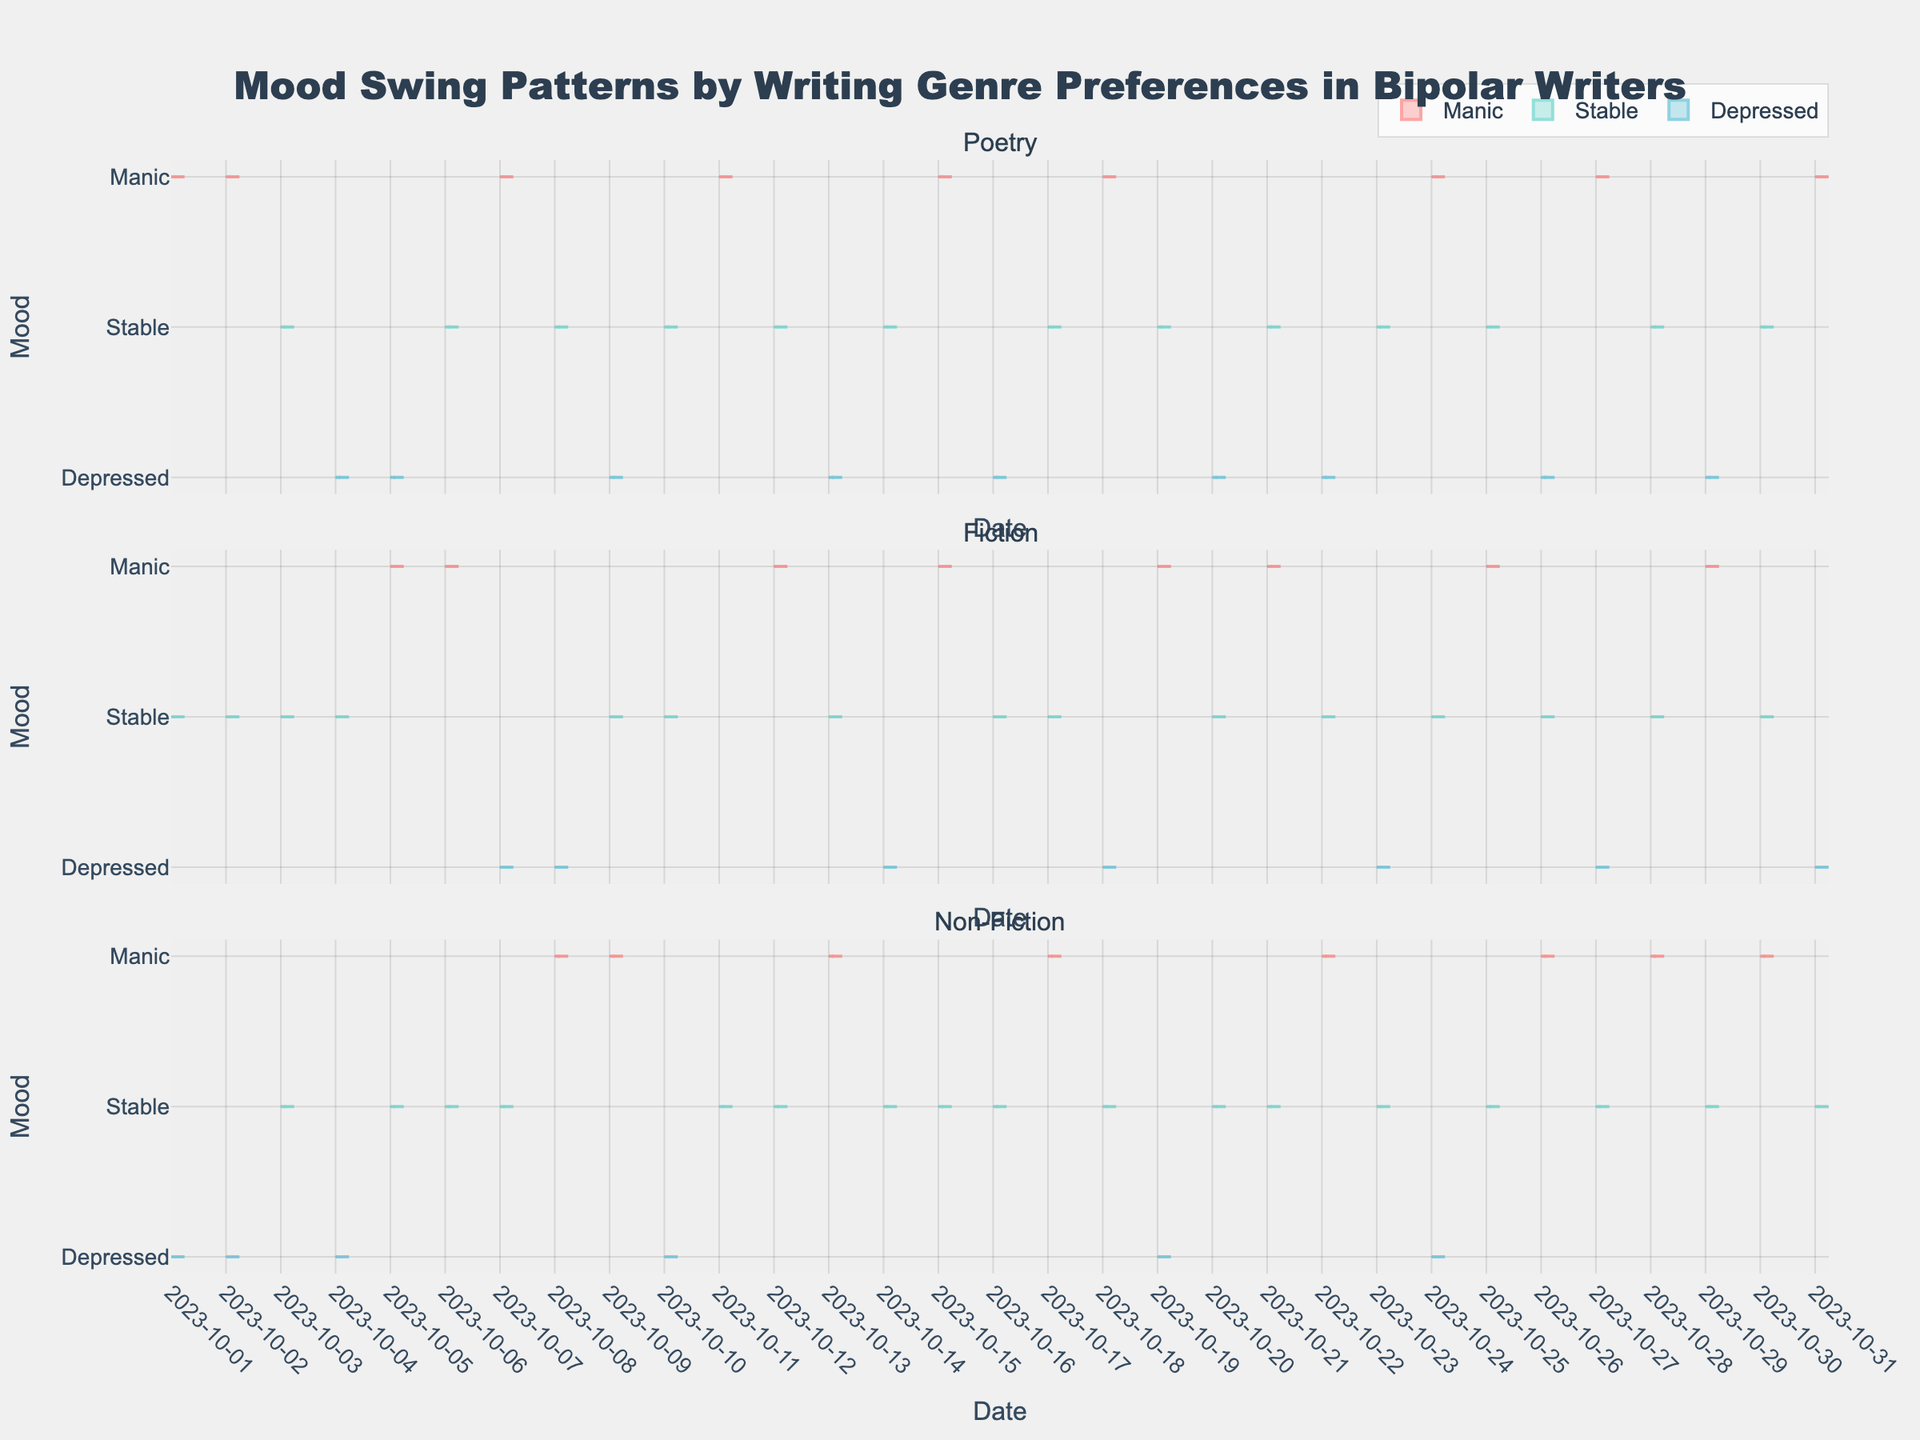What are the genres compared in the figure? The figure has three subplots, each representing a different genre. The titles of the subplots are "Poetry," "Fiction," and "Non-Fiction."
Answer: Poetry, Fiction, Non-Fiction What are the mood categories shown in each subplot? The figure uses different colors to represent three mood categories: Manic, Stable, and Depressed. The legend explains these categories with colors: Manic is red, Stable is green, and Depressed is blue.
Answer: Manic, Stable, Depressed Which mood appears most frequently in the Poetry genre? For the Poetry subplot, visually compare the densities of each color. The green color (representing "Stable") appears more frequently than the other colors.
Answer: Stable How do the mood distributions for Fiction and Non-Fiction writers differ over the month? Examine the densities and spread of each mood category in both the Fiction and Non-Fiction subplots. Fiction shows a relatively equal distribution of Manic, Stable, and Depressed moods, while Non-Fiction shows more frequent appearances of the Stable mood compared to Manic and Depressed.
Answer: Fiction has more balanced distribution; Non-Fiction has more Stable mood Is there a day where all three writers are in a Stable mood? Scan the X-axis for any vertical alignment of the green color "Stable" across all three subplots. The date "2023-10-03" shows all three writers in a stable mood condition.
Answer: 2023-10-03 On which day does Lisa Johnson (Fiction) have a Manic episode and John Smith (Poetry) have a Depressed mood? Look for a point where Lisa Johnson's (green subplot) Manic moods (red) and John Smith's (blue subplot) Depressed moods (blue) align vertically on the X-axis. This alignment happens on "2023-10-05".
Answer: 2023-10-05 Between Poetry and Non-Fiction, which genre shows more Manic episodes? Compare the number of red data points (Manic mood) between the Poetry and Non-Fiction subplots. The Poetry subplot shows more Manic episodes than the Non-Fiction subplot when counting the red sections.
Answer: Poetry What can you infer about mood stability across all genres? By examining consistency and overall spread of the green segments (Stable mood) throughout each subplot, you can see that the Stable mood is present frequently across all three genres, indicating a relative stability compared to other moods.
Answer: Mood stability is relatively high across all genres Which genre shows the highest variability in moods over the month? Check for the genre with the greatest spread of all three mood colors (red for Manic, green for Stable, blue for Depressed). Fiction shows high variability as it displays a noticeable spread of all three mood categories.
Answer: Fiction 